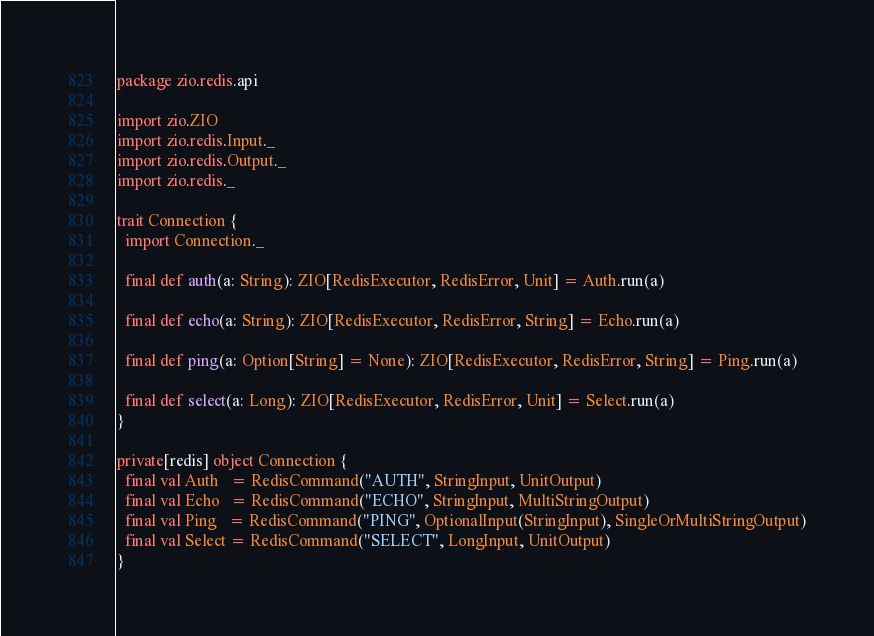<code> <loc_0><loc_0><loc_500><loc_500><_Scala_>package zio.redis.api

import zio.ZIO
import zio.redis.Input._
import zio.redis.Output._
import zio.redis._

trait Connection {
  import Connection._

  final def auth(a: String): ZIO[RedisExecutor, RedisError, Unit] = Auth.run(a)

  final def echo(a: String): ZIO[RedisExecutor, RedisError, String] = Echo.run(a)

  final def ping(a: Option[String] = None): ZIO[RedisExecutor, RedisError, String] = Ping.run(a)

  final def select(a: Long): ZIO[RedisExecutor, RedisError, Unit] = Select.run(a)
}

private[redis] object Connection {
  final val Auth   = RedisCommand("AUTH", StringInput, UnitOutput)
  final val Echo   = RedisCommand("ECHO", StringInput, MultiStringOutput)
  final val Ping   = RedisCommand("PING", OptionalInput(StringInput), SingleOrMultiStringOutput)
  final val Select = RedisCommand("SELECT", LongInput, UnitOutput)
}
</code> 